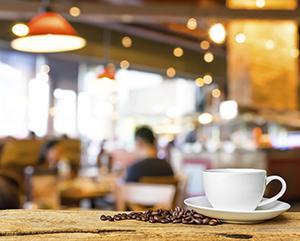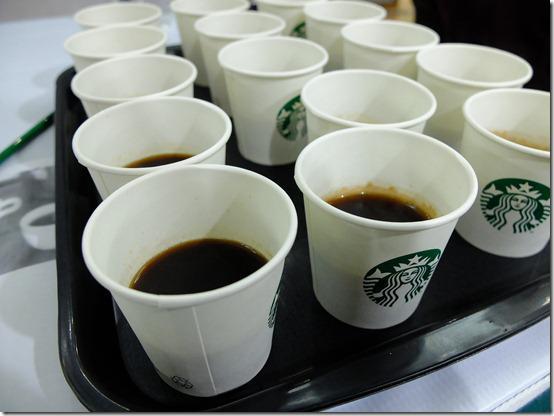The first image is the image on the left, the second image is the image on the right. Examine the images to the left and right. Is the description "All the cups are solid white." accurate? Answer yes or no. No. The first image is the image on the left, the second image is the image on the right. For the images displayed, is the sentence "In at least one image there is a single white cup of coffee on a plate that is all sitting on brown wooden table." factually correct? Answer yes or no. Yes. 